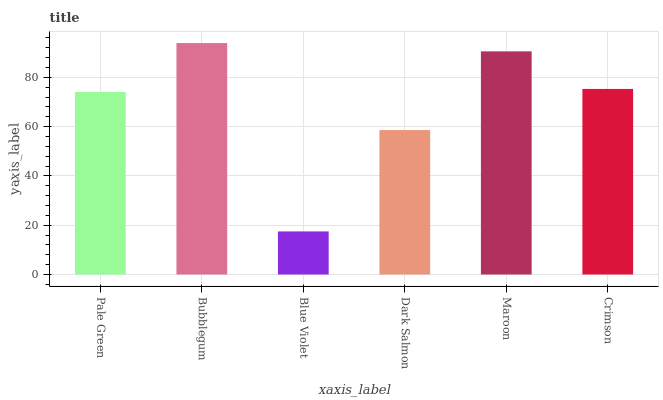Is Blue Violet the minimum?
Answer yes or no. Yes. Is Bubblegum the maximum?
Answer yes or no. Yes. Is Bubblegum the minimum?
Answer yes or no. No. Is Blue Violet the maximum?
Answer yes or no. No. Is Bubblegum greater than Blue Violet?
Answer yes or no. Yes. Is Blue Violet less than Bubblegum?
Answer yes or no. Yes. Is Blue Violet greater than Bubblegum?
Answer yes or no. No. Is Bubblegum less than Blue Violet?
Answer yes or no. No. Is Crimson the high median?
Answer yes or no. Yes. Is Pale Green the low median?
Answer yes or no. Yes. Is Dark Salmon the high median?
Answer yes or no. No. Is Blue Violet the low median?
Answer yes or no. No. 